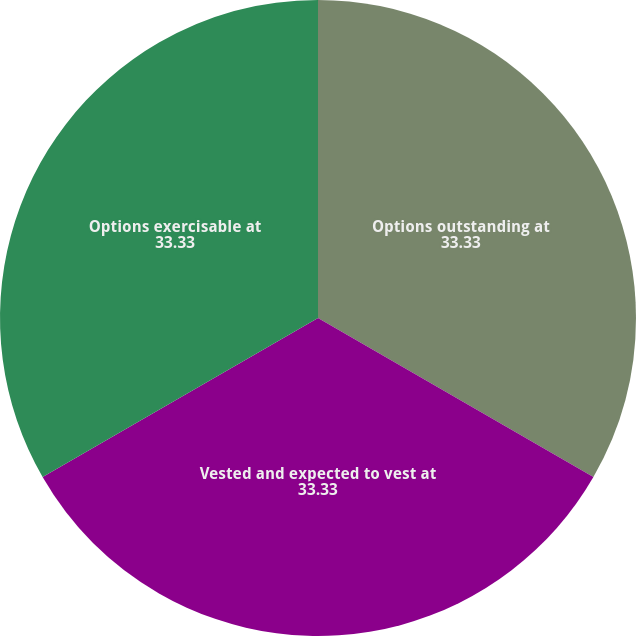<chart> <loc_0><loc_0><loc_500><loc_500><pie_chart><fcel>Options outstanding at<fcel>Vested and expected to vest at<fcel>Options exercisable at<nl><fcel>33.33%<fcel>33.33%<fcel>33.33%<nl></chart> 